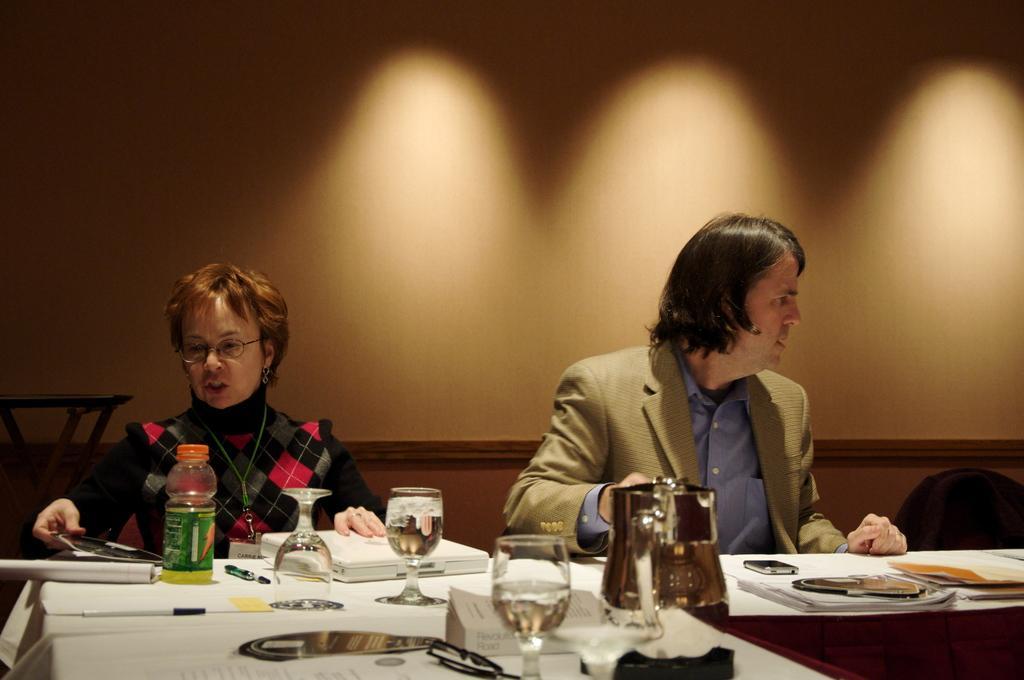Can you describe this image briefly? In this image I see a woman and a man who are sitting on chairs and I see a table in front of them and there are lot of things on it. In the background I see the wall. 